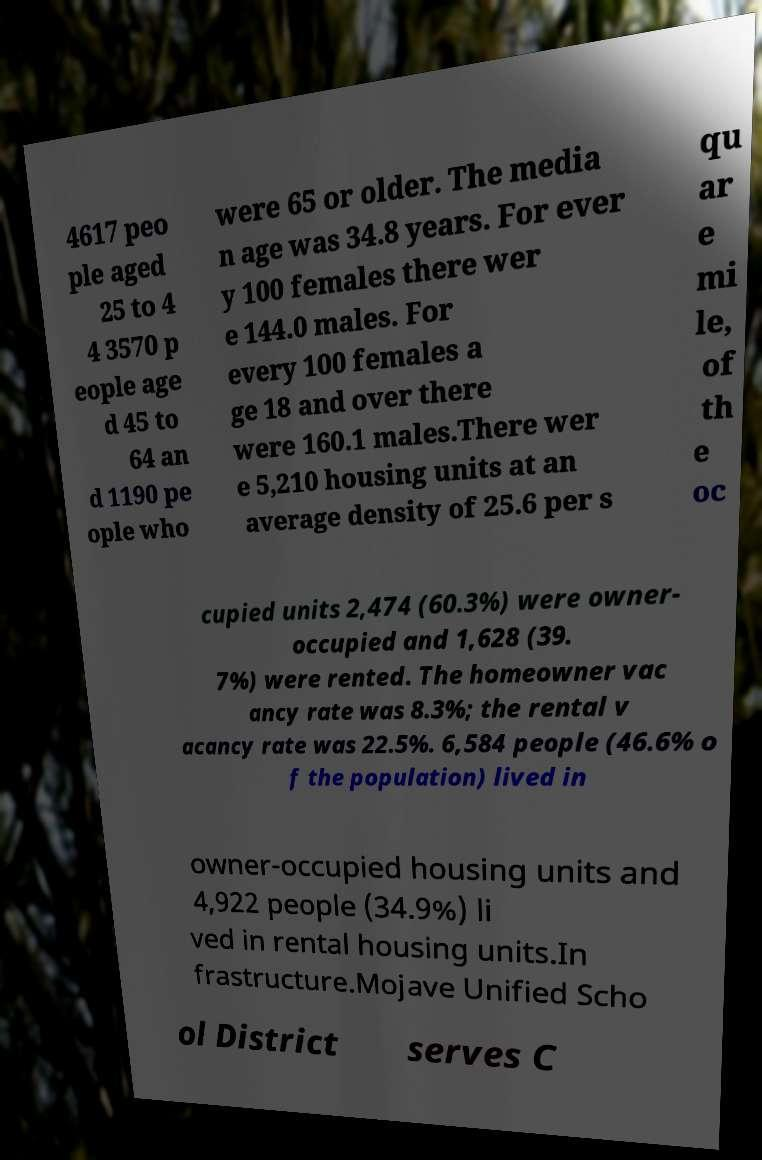I need the written content from this picture converted into text. Can you do that? 4617 peo ple aged 25 to 4 4 3570 p eople age d 45 to 64 an d 1190 pe ople who were 65 or older. The media n age was 34.8 years. For ever y 100 females there wer e 144.0 males. For every 100 females a ge 18 and over there were 160.1 males.There wer e 5,210 housing units at an average density of 25.6 per s qu ar e mi le, of th e oc cupied units 2,474 (60.3%) were owner- occupied and 1,628 (39. 7%) were rented. The homeowner vac ancy rate was 8.3%; the rental v acancy rate was 22.5%. 6,584 people (46.6% o f the population) lived in owner-occupied housing units and 4,922 people (34.9%) li ved in rental housing units.In frastructure.Mojave Unified Scho ol District serves C 